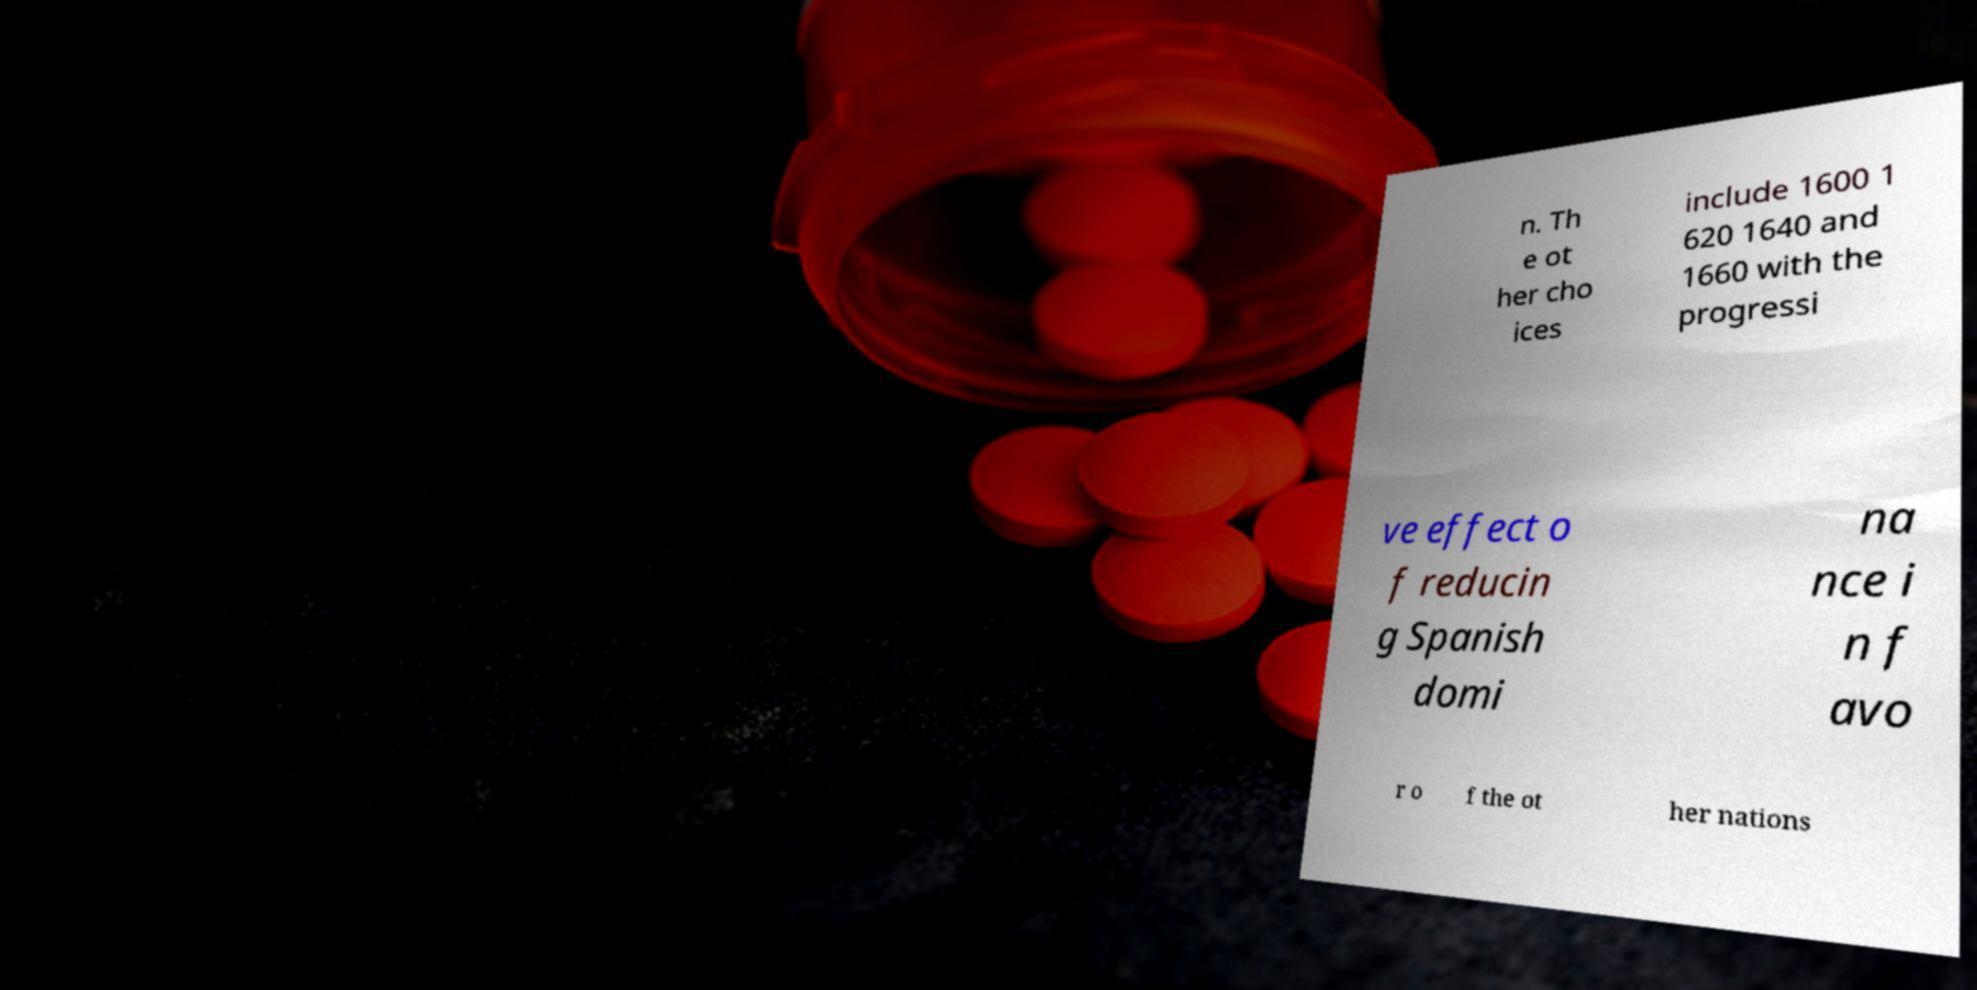Could you extract and type out the text from this image? n. Th e ot her cho ices include 1600 1 620 1640 and 1660 with the progressi ve effect o f reducin g Spanish domi na nce i n f avo r o f the ot her nations 